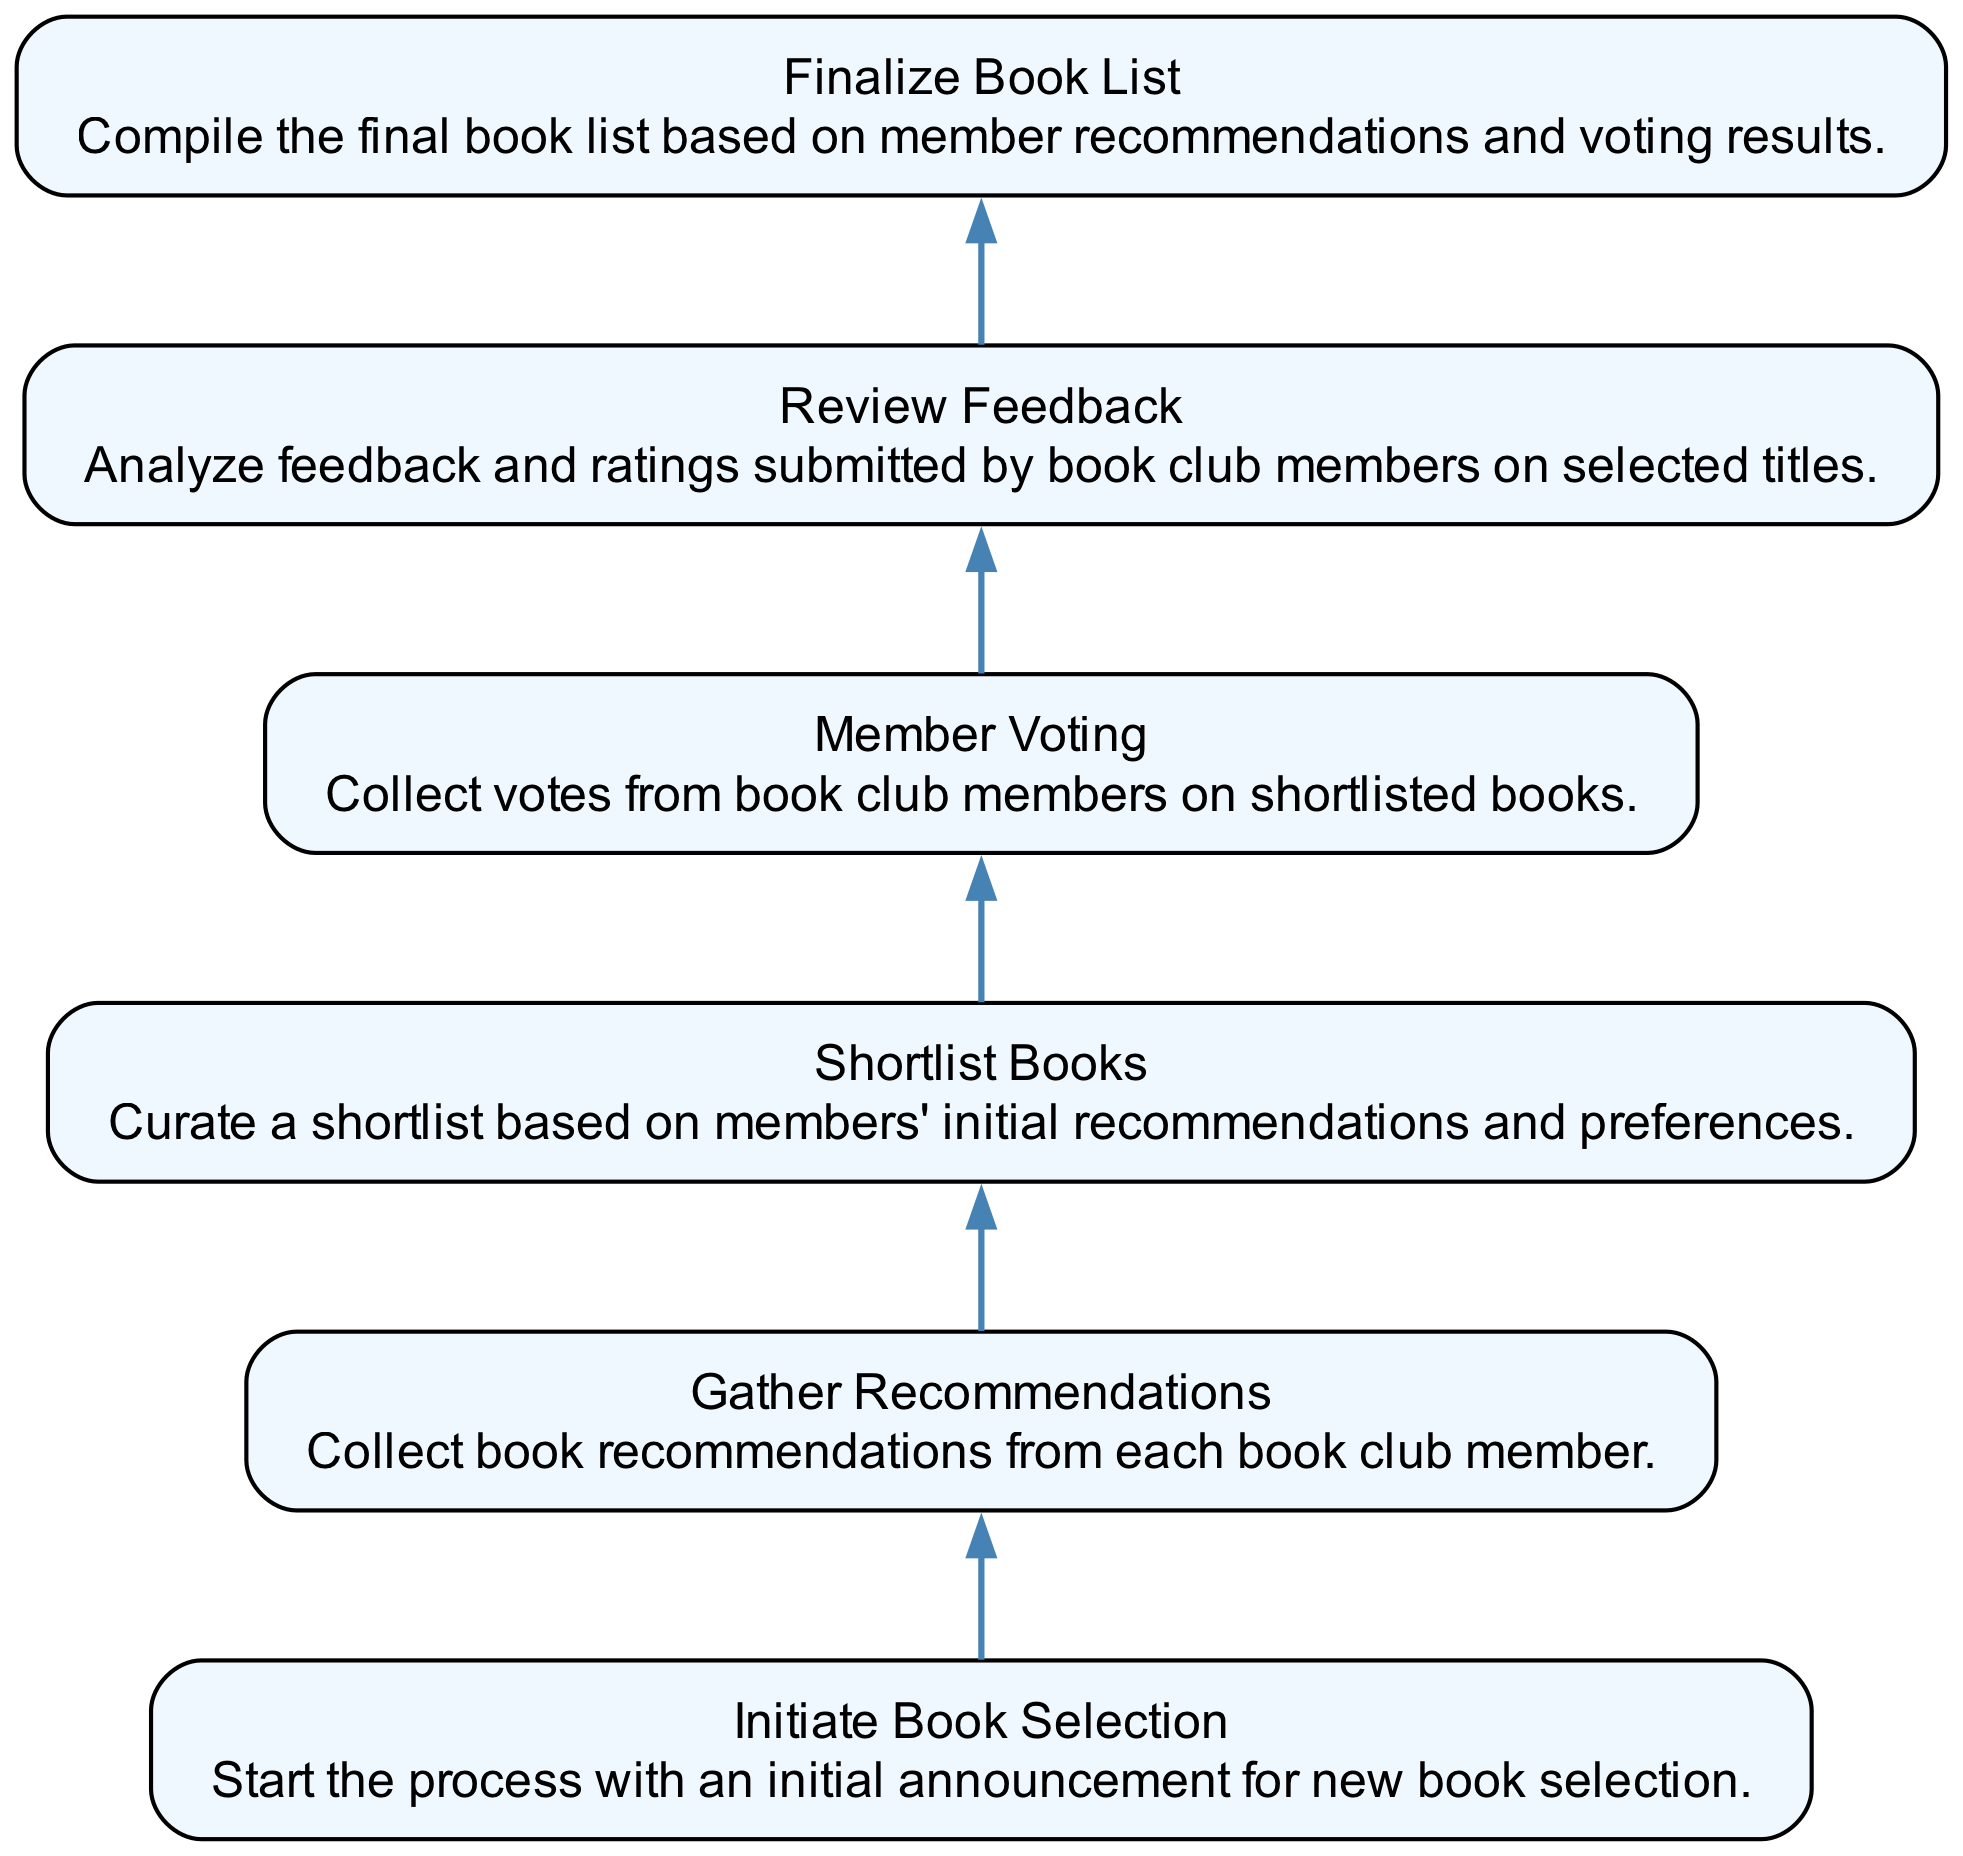What is the first step in the diagram? The first step is represented by the node labeled "Initiate Book Selection," indicating the start of the process for selecting a new book.
Answer: Initiate Book Selection How many nodes are in the diagram? By counting each distinct process represented in the diagram, we find there are a total of six nodes.
Answer: Six What is the final step in the process? The final step is represented by the node labeled "Finalize Book List," indicating the completion of the book selection process.
Answer: Finalize Book List Which step comes immediately after "Gather Recommendations"? The step that follows "Gather Recommendations" is "Shortlist Books," where the club curates a selection based on initial suggestions.
Answer: Shortlist Books What is the relationship between "Member Voting" and "Review Feedback"? "Member Voting" is directly connected to "Review Feedback" in the flow, indicating that votes collected are analyzed before finalizing the book list.
Answer: Member Voting → Review Feedback How many edges are present in the flowchart? Each connection between the nodes represented by arrows can be counted, resulting in a total of five edges in the diagram.
Answer: Five What process occurs after "Shortlist Books"? After the "Shortlist Books" step, the process proceeds to "Member Voting," where members cast their votes on the limited selection of titles.
Answer: Member Voting Which node is connected to "Review Feedback"? The node that is directly connected to "Review Feedback" is "Member Voting," showing that feedback is reviewed after votes are collected.
Answer: Member Voting What action is taken after analyzing member feedback? After analyzing member feedback, the next action is "Finalize Book List," which compiles the final selection of books based on member input and votes.
Answer: Finalize Book List 